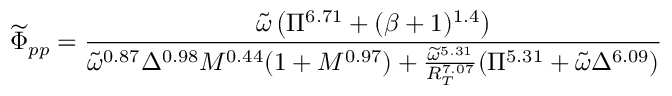<formula> <loc_0><loc_0><loc_500><loc_500>\widetilde { \Phi } _ { p p } = \frac { \widetilde { \omega } \left ( \Pi ^ { 6 . 7 1 } + ( \beta + 1 ) ^ { 1 . 4 } \right ) } { \widetilde { \omega } ^ { 0 . 8 7 } \Delta ^ { 0 . 9 8 } M ^ { 0 . 4 4 } ( 1 + M ^ { 0 . 9 7 } ) + \frac { \widetilde { \omega } ^ { 5 . 3 1 } } { R _ { T } ^ { 7 . 0 7 } } ( \Pi ^ { 5 . 3 1 } + \widetilde { \omega } \Delta ^ { 6 . 0 9 } ) }</formula> 